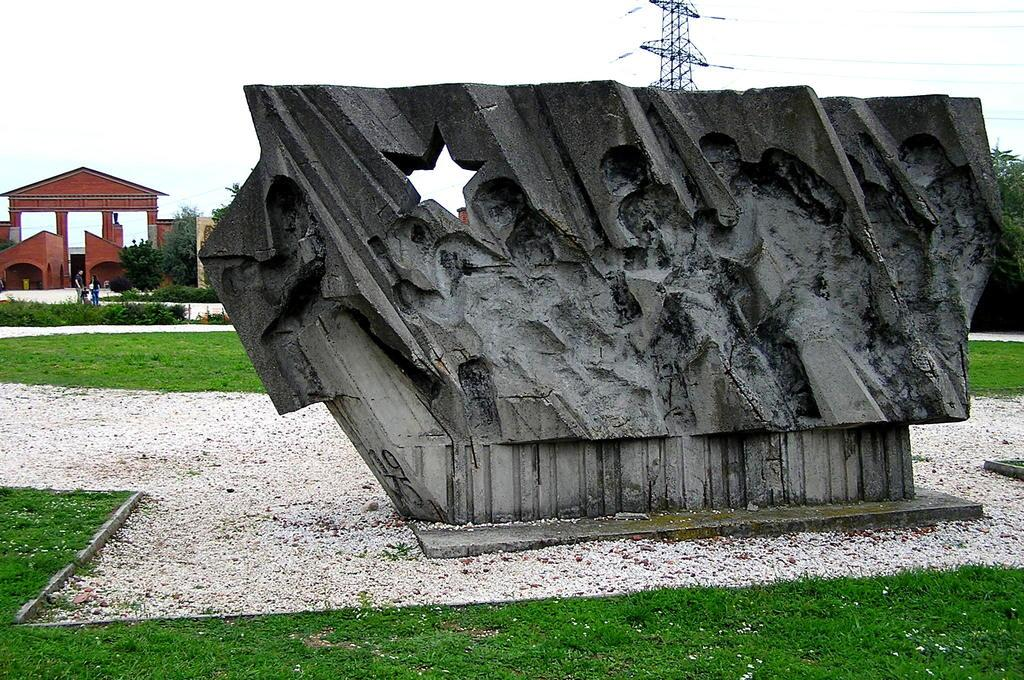What is the main subject of the image? There is a sculpture in the image. What type of natural environment is visible in the image? There is grass and trees in the image. What type of structure is present in the image? There is a building in the image. What are the people in the image doing? The people are standing on the ground in the image. What is visible in the background of the image? The sky is visible in the background of the image. What type of bean is being used in the image? There is no bean present in the image. What holiday is being celebrated in the image? There is no indication of a holiday being celebrated in the image. 